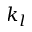Convert formula to latex. <formula><loc_0><loc_0><loc_500><loc_500>k _ { l }</formula> 